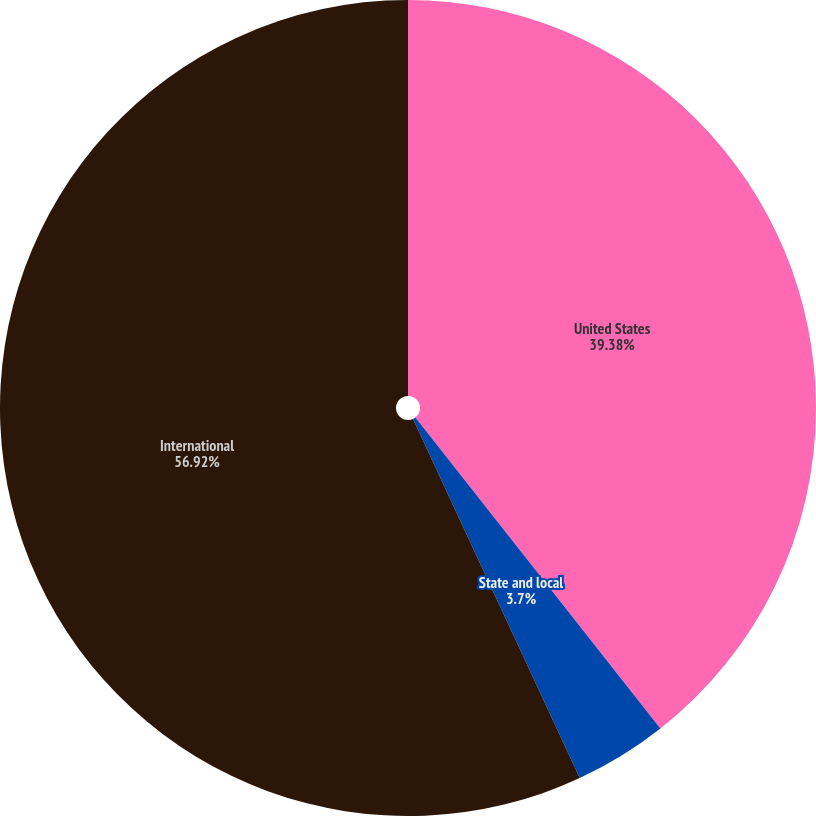Convert chart. <chart><loc_0><loc_0><loc_500><loc_500><pie_chart><fcel>United States<fcel>State and local<fcel>International<nl><fcel>39.38%<fcel>3.7%<fcel>56.91%<nl></chart> 